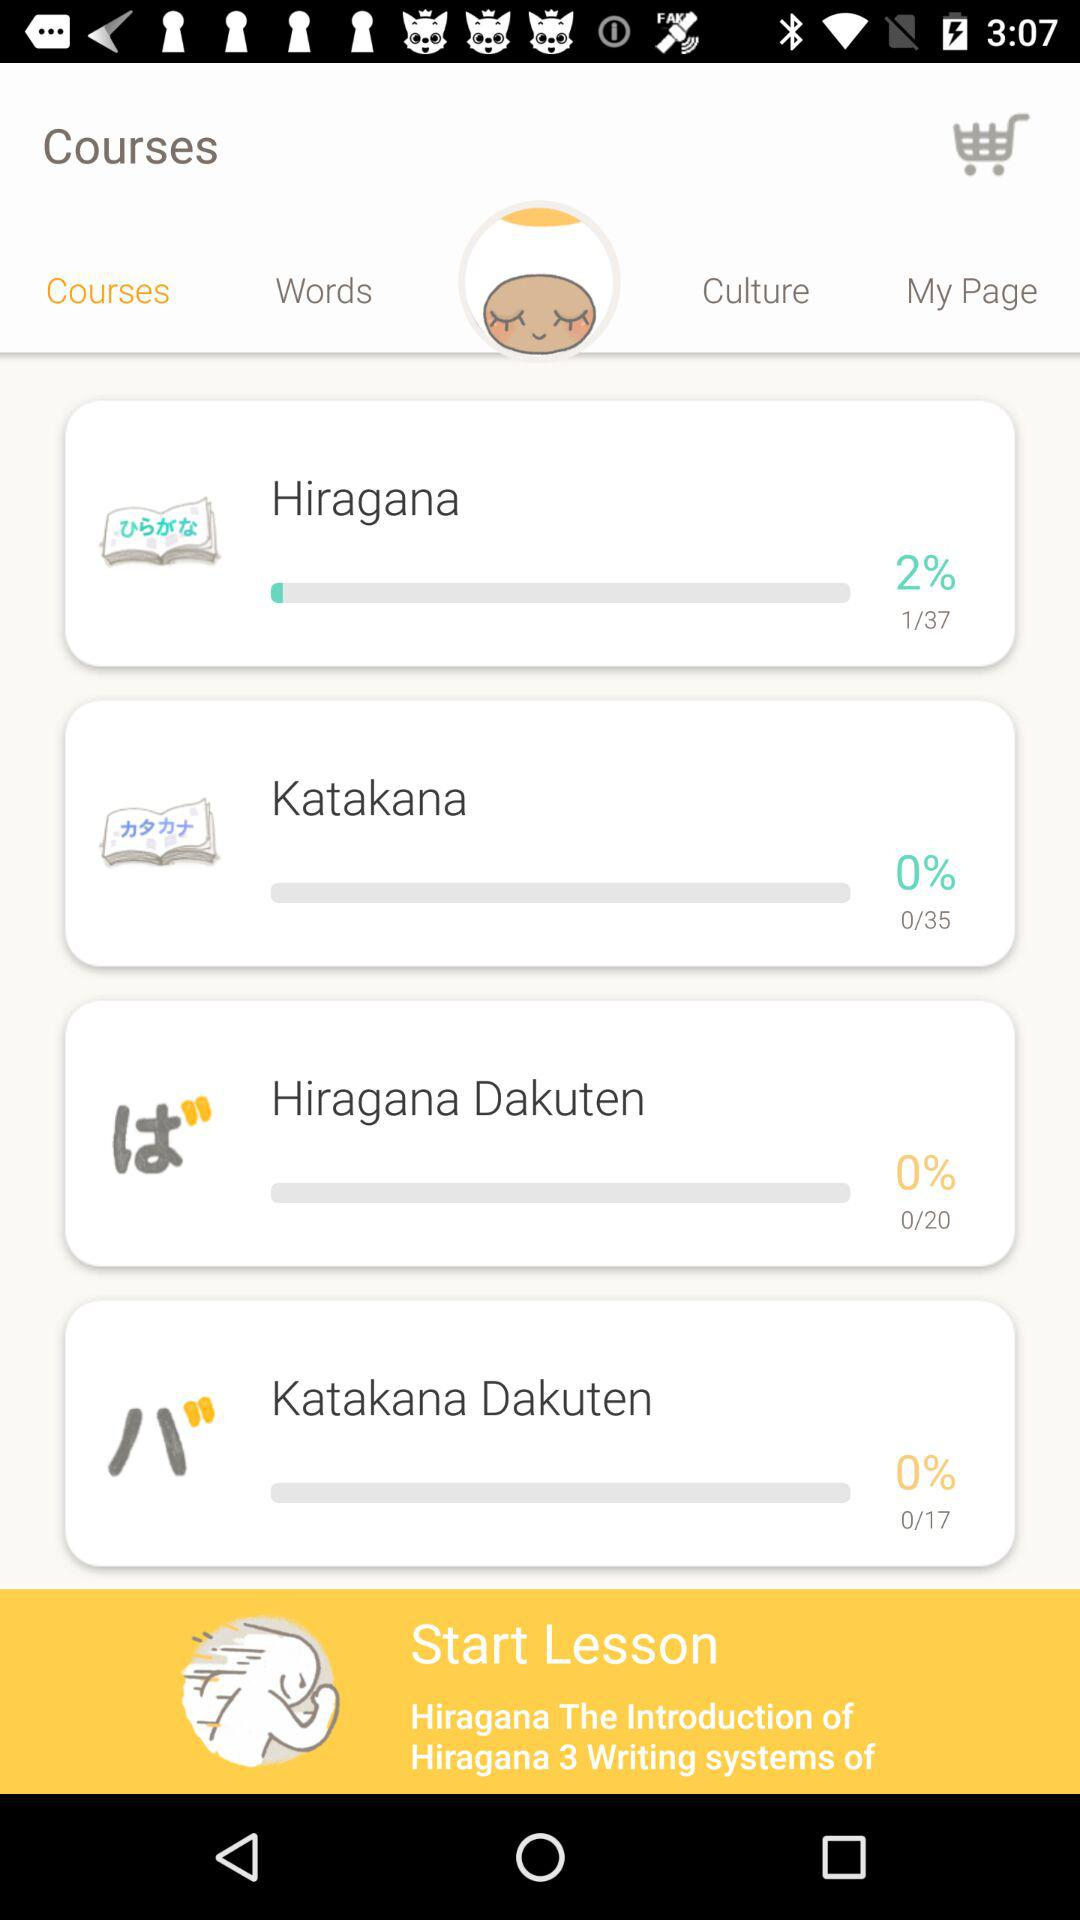How many pages are there in "Hiragana" course? There are 37 pages. 